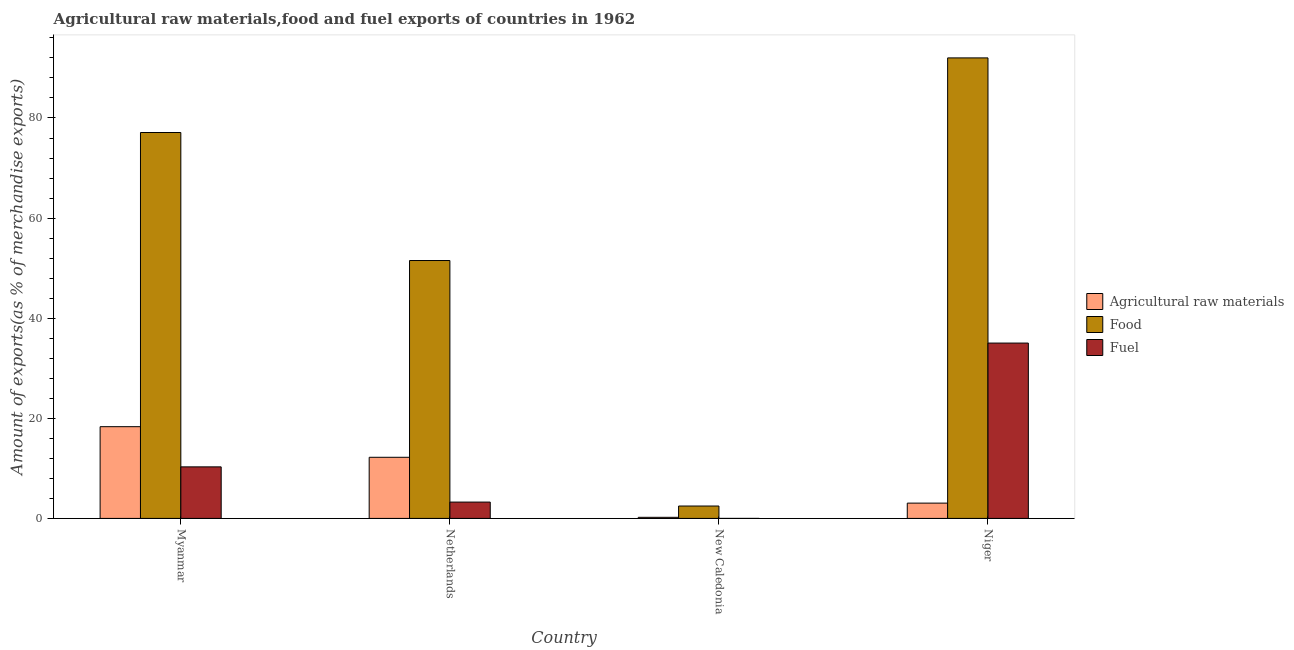How many different coloured bars are there?
Keep it short and to the point. 3. How many groups of bars are there?
Make the answer very short. 4. How many bars are there on the 1st tick from the right?
Your response must be concise. 3. What is the label of the 2nd group of bars from the left?
Provide a short and direct response. Netherlands. In how many cases, is the number of bars for a given country not equal to the number of legend labels?
Provide a succinct answer. 0. What is the percentage of fuel exports in Netherlands?
Give a very brief answer. 3.26. Across all countries, what is the maximum percentage of fuel exports?
Your answer should be compact. 35.03. Across all countries, what is the minimum percentage of food exports?
Your answer should be very brief. 2.47. In which country was the percentage of fuel exports maximum?
Keep it short and to the point. Niger. In which country was the percentage of fuel exports minimum?
Your answer should be very brief. New Caledonia. What is the total percentage of fuel exports in the graph?
Your answer should be compact. 48.59. What is the difference between the percentage of fuel exports in New Caledonia and that in Niger?
Provide a short and direct response. -35.03. What is the difference between the percentage of food exports in Niger and the percentage of raw materials exports in Myanmar?
Your answer should be compact. 73.68. What is the average percentage of fuel exports per country?
Offer a very short reply. 12.15. What is the difference between the percentage of raw materials exports and percentage of fuel exports in Niger?
Keep it short and to the point. -31.97. What is the ratio of the percentage of food exports in Myanmar to that in New Caledonia?
Give a very brief answer. 31.17. Is the difference between the percentage of fuel exports in Netherlands and Niger greater than the difference between the percentage of food exports in Netherlands and Niger?
Give a very brief answer. Yes. What is the difference between the highest and the second highest percentage of food exports?
Provide a succinct answer. 14.91. What is the difference between the highest and the lowest percentage of fuel exports?
Provide a short and direct response. 35.03. What does the 2nd bar from the left in Niger represents?
Offer a very short reply. Food. What does the 2nd bar from the right in Myanmar represents?
Ensure brevity in your answer.  Food. Is it the case that in every country, the sum of the percentage of raw materials exports and percentage of food exports is greater than the percentage of fuel exports?
Give a very brief answer. Yes. How many countries are there in the graph?
Make the answer very short. 4. What is the difference between two consecutive major ticks on the Y-axis?
Provide a short and direct response. 20. Does the graph contain any zero values?
Offer a terse response. No. Where does the legend appear in the graph?
Your response must be concise. Center right. How many legend labels are there?
Ensure brevity in your answer.  3. What is the title of the graph?
Your response must be concise. Agricultural raw materials,food and fuel exports of countries in 1962. Does "Tertiary" appear as one of the legend labels in the graph?
Ensure brevity in your answer.  No. What is the label or title of the Y-axis?
Offer a very short reply. Amount of exports(as % of merchandise exports). What is the Amount of exports(as % of merchandise exports) of Agricultural raw materials in Myanmar?
Your response must be concise. 18.33. What is the Amount of exports(as % of merchandise exports) of Food in Myanmar?
Your response must be concise. 77.1. What is the Amount of exports(as % of merchandise exports) of Fuel in Myanmar?
Provide a succinct answer. 10.3. What is the Amount of exports(as % of merchandise exports) in Agricultural raw materials in Netherlands?
Offer a terse response. 12.21. What is the Amount of exports(as % of merchandise exports) of Food in Netherlands?
Your response must be concise. 51.52. What is the Amount of exports(as % of merchandise exports) in Fuel in Netherlands?
Your response must be concise. 3.26. What is the Amount of exports(as % of merchandise exports) in Agricultural raw materials in New Caledonia?
Ensure brevity in your answer.  0.22. What is the Amount of exports(as % of merchandise exports) in Food in New Caledonia?
Offer a terse response. 2.47. What is the Amount of exports(as % of merchandise exports) of Fuel in New Caledonia?
Provide a short and direct response. 5.864290748011679e-5. What is the Amount of exports(as % of merchandise exports) of Agricultural raw materials in Niger?
Your answer should be compact. 3.06. What is the Amount of exports(as % of merchandise exports) in Food in Niger?
Your answer should be compact. 92.01. What is the Amount of exports(as % of merchandise exports) of Fuel in Niger?
Your response must be concise. 35.03. Across all countries, what is the maximum Amount of exports(as % of merchandise exports) of Agricultural raw materials?
Your response must be concise. 18.33. Across all countries, what is the maximum Amount of exports(as % of merchandise exports) of Food?
Keep it short and to the point. 92.01. Across all countries, what is the maximum Amount of exports(as % of merchandise exports) in Fuel?
Your answer should be very brief. 35.03. Across all countries, what is the minimum Amount of exports(as % of merchandise exports) of Agricultural raw materials?
Your answer should be compact. 0.22. Across all countries, what is the minimum Amount of exports(as % of merchandise exports) of Food?
Offer a terse response. 2.47. Across all countries, what is the minimum Amount of exports(as % of merchandise exports) of Fuel?
Your response must be concise. 5.864290748011679e-5. What is the total Amount of exports(as % of merchandise exports) in Agricultural raw materials in the graph?
Your answer should be very brief. 33.81. What is the total Amount of exports(as % of merchandise exports) in Food in the graph?
Keep it short and to the point. 223.1. What is the total Amount of exports(as % of merchandise exports) in Fuel in the graph?
Your response must be concise. 48.59. What is the difference between the Amount of exports(as % of merchandise exports) in Agricultural raw materials in Myanmar and that in Netherlands?
Your answer should be compact. 6.12. What is the difference between the Amount of exports(as % of merchandise exports) of Food in Myanmar and that in Netherlands?
Make the answer very short. 25.57. What is the difference between the Amount of exports(as % of merchandise exports) of Fuel in Myanmar and that in Netherlands?
Your answer should be very brief. 7.04. What is the difference between the Amount of exports(as % of merchandise exports) of Agricultural raw materials in Myanmar and that in New Caledonia?
Your response must be concise. 18.11. What is the difference between the Amount of exports(as % of merchandise exports) of Food in Myanmar and that in New Caledonia?
Give a very brief answer. 74.62. What is the difference between the Amount of exports(as % of merchandise exports) in Fuel in Myanmar and that in New Caledonia?
Ensure brevity in your answer.  10.3. What is the difference between the Amount of exports(as % of merchandise exports) in Agricultural raw materials in Myanmar and that in Niger?
Ensure brevity in your answer.  15.27. What is the difference between the Amount of exports(as % of merchandise exports) in Food in Myanmar and that in Niger?
Offer a very short reply. -14.91. What is the difference between the Amount of exports(as % of merchandise exports) of Fuel in Myanmar and that in Niger?
Offer a very short reply. -24.73. What is the difference between the Amount of exports(as % of merchandise exports) in Agricultural raw materials in Netherlands and that in New Caledonia?
Keep it short and to the point. 11.99. What is the difference between the Amount of exports(as % of merchandise exports) in Food in Netherlands and that in New Caledonia?
Your answer should be very brief. 49.05. What is the difference between the Amount of exports(as % of merchandise exports) of Fuel in Netherlands and that in New Caledonia?
Offer a very short reply. 3.26. What is the difference between the Amount of exports(as % of merchandise exports) in Agricultural raw materials in Netherlands and that in Niger?
Your answer should be very brief. 9.15. What is the difference between the Amount of exports(as % of merchandise exports) in Food in Netherlands and that in Niger?
Offer a very short reply. -40.48. What is the difference between the Amount of exports(as % of merchandise exports) of Fuel in Netherlands and that in Niger?
Offer a very short reply. -31.77. What is the difference between the Amount of exports(as % of merchandise exports) of Agricultural raw materials in New Caledonia and that in Niger?
Give a very brief answer. -2.84. What is the difference between the Amount of exports(as % of merchandise exports) of Food in New Caledonia and that in Niger?
Your answer should be very brief. -89.53. What is the difference between the Amount of exports(as % of merchandise exports) of Fuel in New Caledonia and that in Niger?
Your answer should be compact. -35.03. What is the difference between the Amount of exports(as % of merchandise exports) of Agricultural raw materials in Myanmar and the Amount of exports(as % of merchandise exports) of Food in Netherlands?
Offer a terse response. -33.2. What is the difference between the Amount of exports(as % of merchandise exports) in Agricultural raw materials in Myanmar and the Amount of exports(as % of merchandise exports) in Fuel in Netherlands?
Keep it short and to the point. 15.07. What is the difference between the Amount of exports(as % of merchandise exports) of Food in Myanmar and the Amount of exports(as % of merchandise exports) of Fuel in Netherlands?
Ensure brevity in your answer.  73.84. What is the difference between the Amount of exports(as % of merchandise exports) in Agricultural raw materials in Myanmar and the Amount of exports(as % of merchandise exports) in Food in New Caledonia?
Your response must be concise. 15.85. What is the difference between the Amount of exports(as % of merchandise exports) in Agricultural raw materials in Myanmar and the Amount of exports(as % of merchandise exports) in Fuel in New Caledonia?
Offer a terse response. 18.33. What is the difference between the Amount of exports(as % of merchandise exports) in Food in Myanmar and the Amount of exports(as % of merchandise exports) in Fuel in New Caledonia?
Provide a succinct answer. 77.1. What is the difference between the Amount of exports(as % of merchandise exports) of Agricultural raw materials in Myanmar and the Amount of exports(as % of merchandise exports) of Food in Niger?
Your answer should be very brief. -73.68. What is the difference between the Amount of exports(as % of merchandise exports) of Agricultural raw materials in Myanmar and the Amount of exports(as % of merchandise exports) of Fuel in Niger?
Make the answer very short. -16.7. What is the difference between the Amount of exports(as % of merchandise exports) in Food in Myanmar and the Amount of exports(as % of merchandise exports) in Fuel in Niger?
Offer a terse response. 42.07. What is the difference between the Amount of exports(as % of merchandise exports) of Agricultural raw materials in Netherlands and the Amount of exports(as % of merchandise exports) of Food in New Caledonia?
Give a very brief answer. 9.74. What is the difference between the Amount of exports(as % of merchandise exports) of Agricultural raw materials in Netherlands and the Amount of exports(as % of merchandise exports) of Fuel in New Caledonia?
Provide a succinct answer. 12.21. What is the difference between the Amount of exports(as % of merchandise exports) of Food in Netherlands and the Amount of exports(as % of merchandise exports) of Fuel in New Caledonia?
Your answer should be very brief. 51.52. What is the difference between the Amount of exports(as % of merchandise exports) in Agricultural raw materials in Netherlands and the Amount of exports(as % of merchandise exports) in Food in Niger?
Provide a short and direct response. -79.79. What is the difference between the Amount of exports(as % of merchandise exports) of Agricultural raw materials in Netherlands and the Amount of exports(as % of merchandise exports) of Fuel in Niger?
Your response must be concise. -22.82. What is the difference between the Amount of exports(as % of merchandise exports) of Food in Netherlands and the Amount of exports(as % of merchandise exports) of Fuel in Niger?
Make the answer very short. 16.49. What is the difference between the Amount of exports(as % of merchandise exports) of Agricultural raw materials in New Caledonia and the Amount of exports(as % of merchandise exports) of Food in Niger?
Provide a short and direct response. -91.79. What is the difference between the Amount of exports(as % of merchandise exports) of Agricultural raw materials in New Caledonia and the Amount of exports(as % of merchandise exports) of Fuel in Niger?
Provide a short and direct response. -34.81. What is the difference between the Amount of exports(as % of merchandise exports) of Food in New Caledonia and the Amount of exports(as % of merchandise exports) of Fuel in Niger?
Provide a short and direct response. -32.56. What is the average Amount of exports(as % of merchandise exports) in Agricultural raw materials per country?
Provide a succinct answer. 8.45. What is the average Amount of exports(as % of merchandise exports) in Food per country?
Keep it short and to the point. 55.78. What is the average Amount of exports(as % of merchandise exports) of Fuel per country?
Ensure brevity in your answer.  12.15. What is the difference between the Amount of exports(as % of merchandise exports) in Agricultural raw materials and Amount of exports(as % of merchandise exports) in Food in Myanmar?
Give a very brief answer. -58.77. What is the difference between the Amount of exports(as % of merchandise exports) in Agricultural raw materials and Amount of exports(as % of merchandise exports) in Fuel in Myanmar?
Make the answer very short. 8.03. What is the difference between the Amount of exports(as % of merchandise exports) of Food and Amount of exports(as % of merchandise exports) of Fuel in Myanmar?
Your response must be concise. 66.8. What is the difference between the Amount of exports(as % of merchandise exports) in Agricultural raw materials and Amount of exports(as % of merchandise exports) in Food in Netherlands?
Keep it short and to the point. -39.31. What is the difference between the Amount of exports(as % of merchandise exports) in Agricultural raw materials and Amount of exports(as % of merchandise exports) in Fuel in Netherlands?
Make the answer very short. 8.95. What is the difference between the Amount of exports(as % of merchandise exports) in Food and Amount of exports(as % of merchandise exports) in Fuel in Netherlands?
Ensure brevity in your answer.  48.26. What is the difference between the Amount of exports(as % of merchandise exports) in Agricultural raw materials and Amount of exports(as % of merchandise exports) in Food in New Caledonia?
Offer a very short reply. -2.26. What is the difference between the Amount of exports(as % of merchandise exports) of Agricultural raw materials and Amount of exports(as % of merchandise exports) of Fuel in New Caledonia?
Give a very brief answer. 0.22. What is the difference between the Amount of exports(as % of merchandise exports) in Food and Amount of exports(as % of merchandise exports) in Fuel in New Caledonia?
Give a very brief answer. 2.47. What is the difference between the Amount of exports(as % of merchandise exports) in Agricultural raw materials and Amount of exports(as % of merchandise exports) in Food in Niger?
Your answer should be compact. -88.95. What is the difference between the Amount of exports(as % of merchandise exports) of Agricultural raw materials and Amount of exports(as % of merchandise exports) of Fuel in Niger?
Provide a succinct answer. -31.97. What is the difference between the Amount of exports(as % of merchandise exports) of Food and Amount of exports(as % of merchandise exports) of Fuel in Niger?
Keep it short and to the point. 56.98. What is the ratio of the Amount of exports(as % of merchandise exports) of Agricultural raw materials in Myanmar to that in Netherlands?
Give a very brief answer. 1.5. What is the ratio of the Amount of exports(as % of merchandise exports) of Food in Myanmar to that in Netherlands?
Provide a succinct answer. 1.5. What is the ratio of the Amount of exports(as % of merchandise exports) of Fuel in Myanmar to that in Netherlands?
Provide a short and direct response. 3.16. What is the ratio of the Amount of exports(as % of merchandise exports) in Agricultural raw materials in Myanmar to that in New Caledonia?
Your answer should be compact. 83.98. What is the ratio of the Amount of exports(as % of merchandise exports) in Food in Myanmar to that in New Caledonia?
Keep it short and to the point. 31.17. What is the ratio of the Amount of exports(as % of merchandise exports) of Fuel in Myanmar to that in New Caledonia?
Provide a short and direct response. 1.76e+05. What is the ratio of the Amount of exports(as % of merchandise exports) of Agricultural raw materials in Myanmar to that in Niger?
Keep it short and to the point. 6. What is the ratio of the Amount of exports(as % of merchandise exports) of Food in Myanmar to that in Niger?
Provide a short and direct response. 0.84. What is the ratio of the Amount of exports(as % of merchandise exports) in Fuel in Myanmar to that in Niger?
Give a very brief answer. 0.29. What is the ratio of the Amount of exports(as % of merchandise exports) of Agricultural raw materials in Netherlands to that in New Caledonia?
Offer a very short reply. 55.95. What is the ratio of the Amount of exports(as % of merchandise exports) of Food in Netherlands to that in New Caledonia?
Make the answer very short. 20.83. What is the ratio of the Amount of exports(as % of merchandise exports) in Fuel in Netherlands to that in New Caledonia?
Make the answer very short. 5.56e+04. What is the ratio of the Amount of exports(as % of merchandise exports) of Agricultural raw materials in Netherlands to that in Niger?
Offer a very short reply. 4. What is the ratio of the Amount of exports(as % of merchandise exports) of Food in Netherlands to that in Niger?
Your answer should be compact. 0.56. What is the ratio of the Amount of exports(as % of merchandise exports) of Fuel in Netherlands to that in Niger?
Offer a terse response. 0.09. What is the ratio of the Amount of exports(as % of merchandise exports) in Agricultural raw materials in New Caledonia to that in Niger?
Provide a short and direct response. 0.07. What is the ratio of the Amount of exports(as % of merchandise exports) of Food in New Caledonia to that in Niger?
Give a very brief answer. 0.03. What is the difference between the highest and the second highest Amount of exports(as % of merchandise exports) of Agricultural raw materials?
Offer a terse response. 6.12. What is the difference between the highest and the second highest Amount of exports(as % of merchandise exports) in Food?
Offer a terse response. 14.91. What is the difference between the highest and the second highest Amount of exports(as % of merchandise exports) in Fuel?
Your answer should be very brief. 24.73. What is the difference between the highest and the lowest Amount of exports(as % of merchandise exports) of Agricultural raw materials?
Offer a terse response. 18.11. What is the difference between the highest and the lowest Amount of exports(as % of merchandise exports) of Food?
Your answer should be compact. 89.53. What is the difference between the highest and the lowest Amount of exports(as % of merchandise exports) of Fuel?
Your response must be concise. 35.03. 